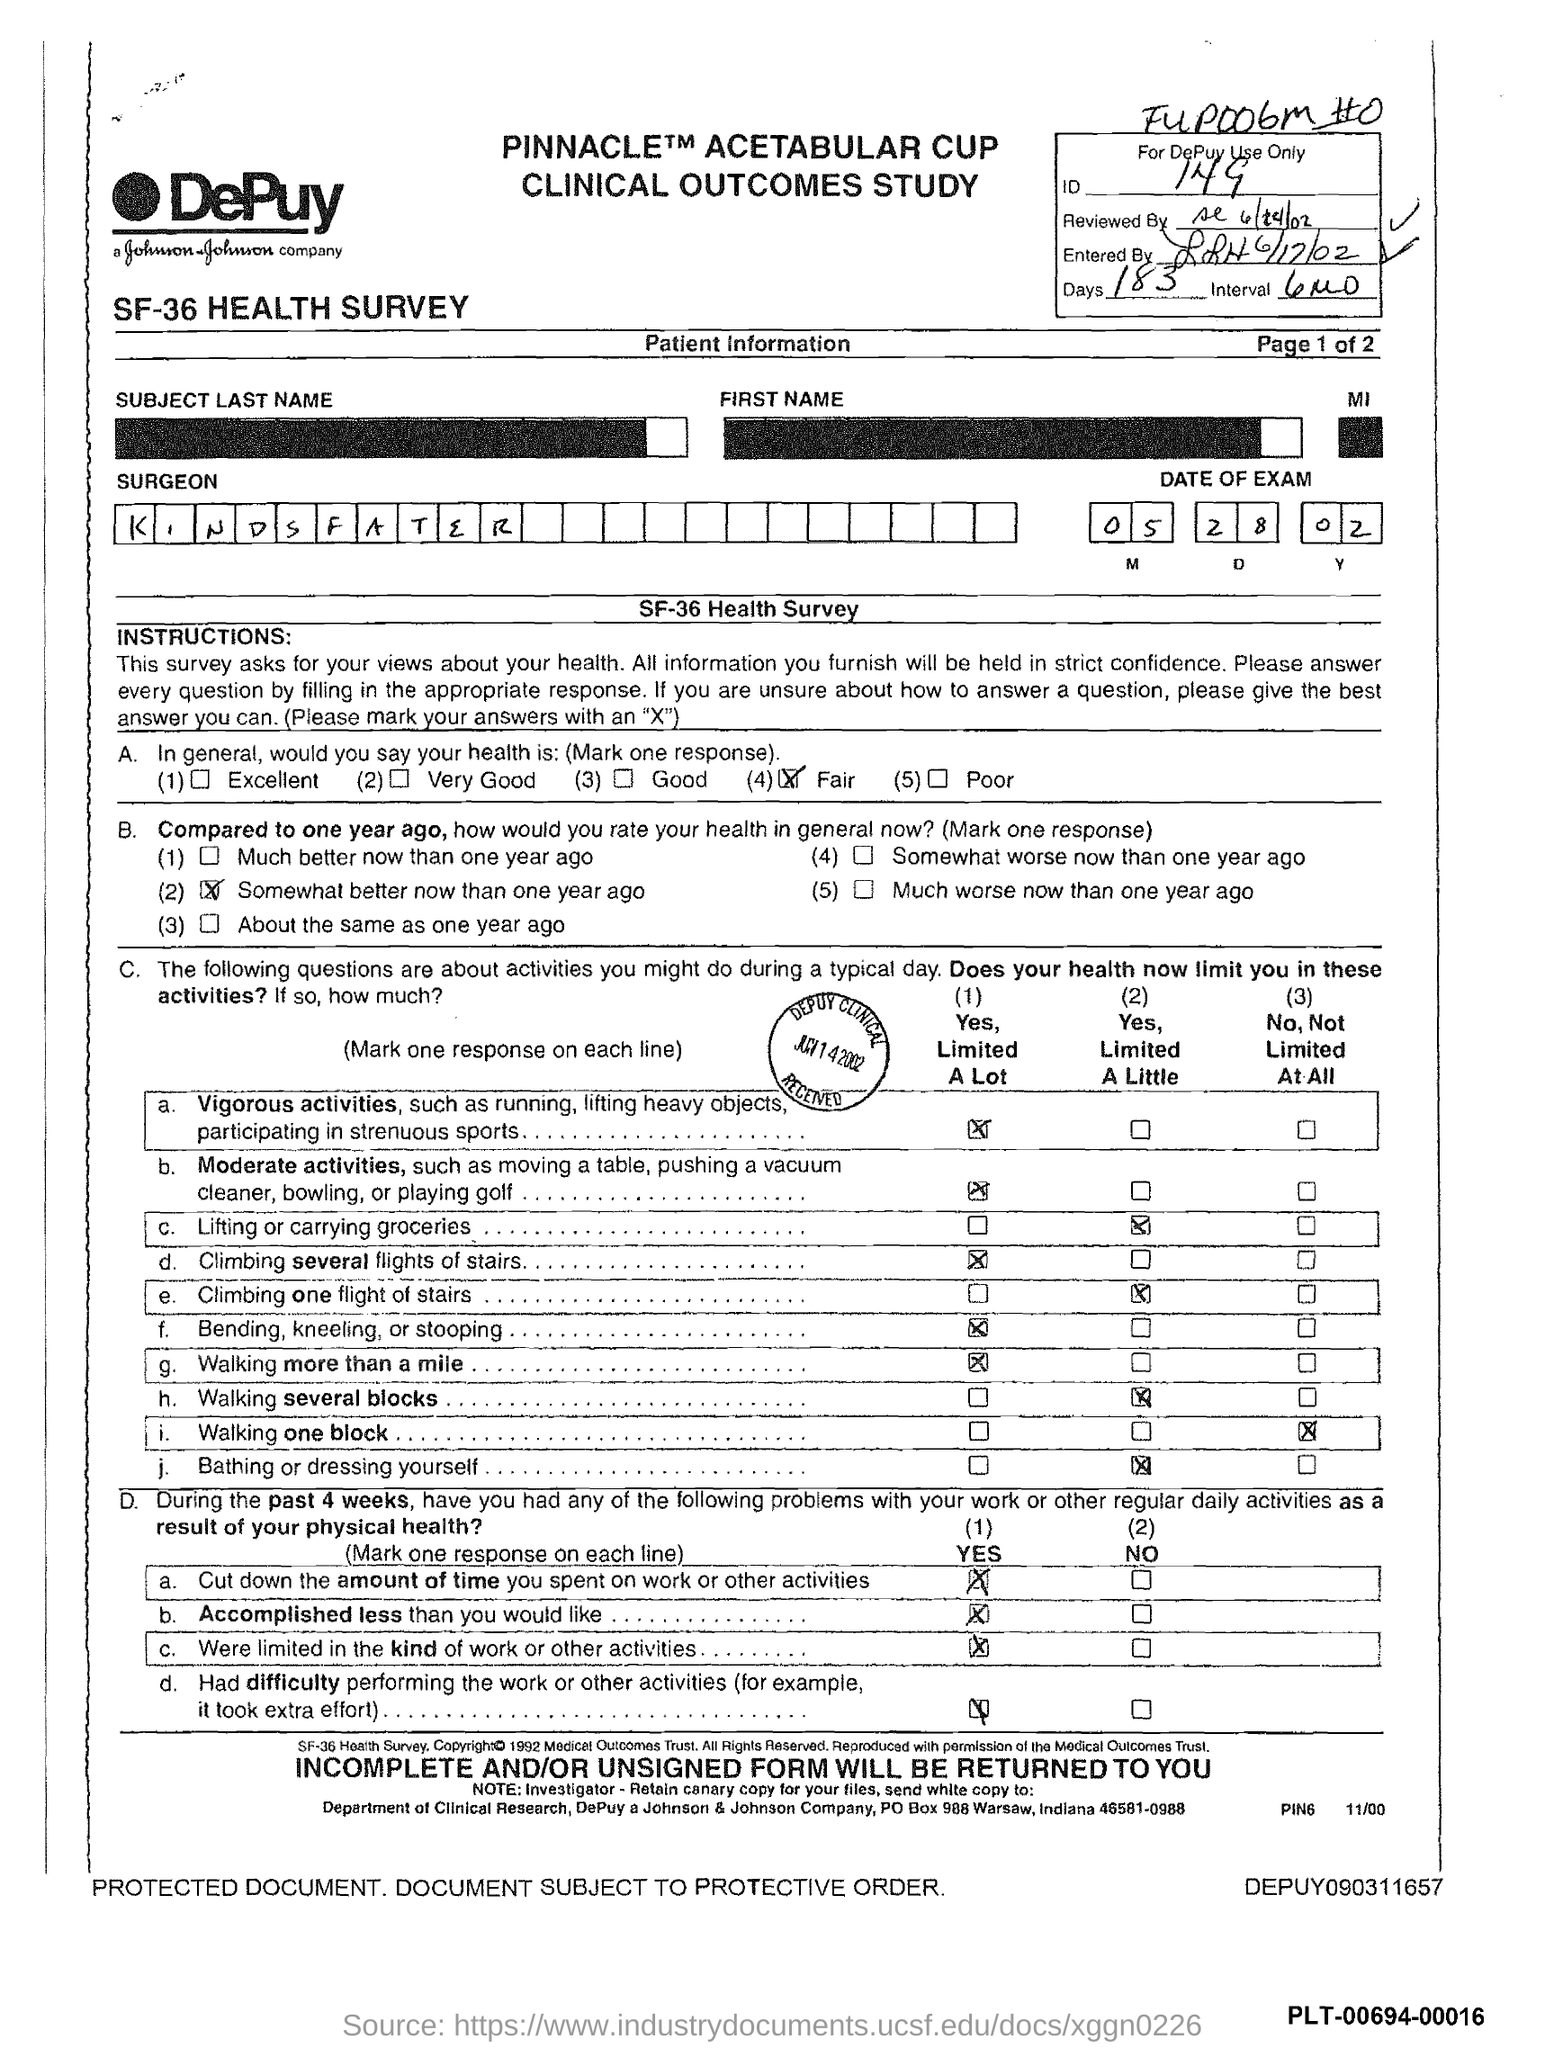What is the no of days given in the form?
Keep it short and to the point. 183. What is the ID mentioned in the form?
Your response must be concise. 149. What is the surgeon's name mentioned in the form?
Keep it short and to the point. KINDSFATER. What is the date of the exam given in the form?
Provide a succinct answer. 05 28 02. 